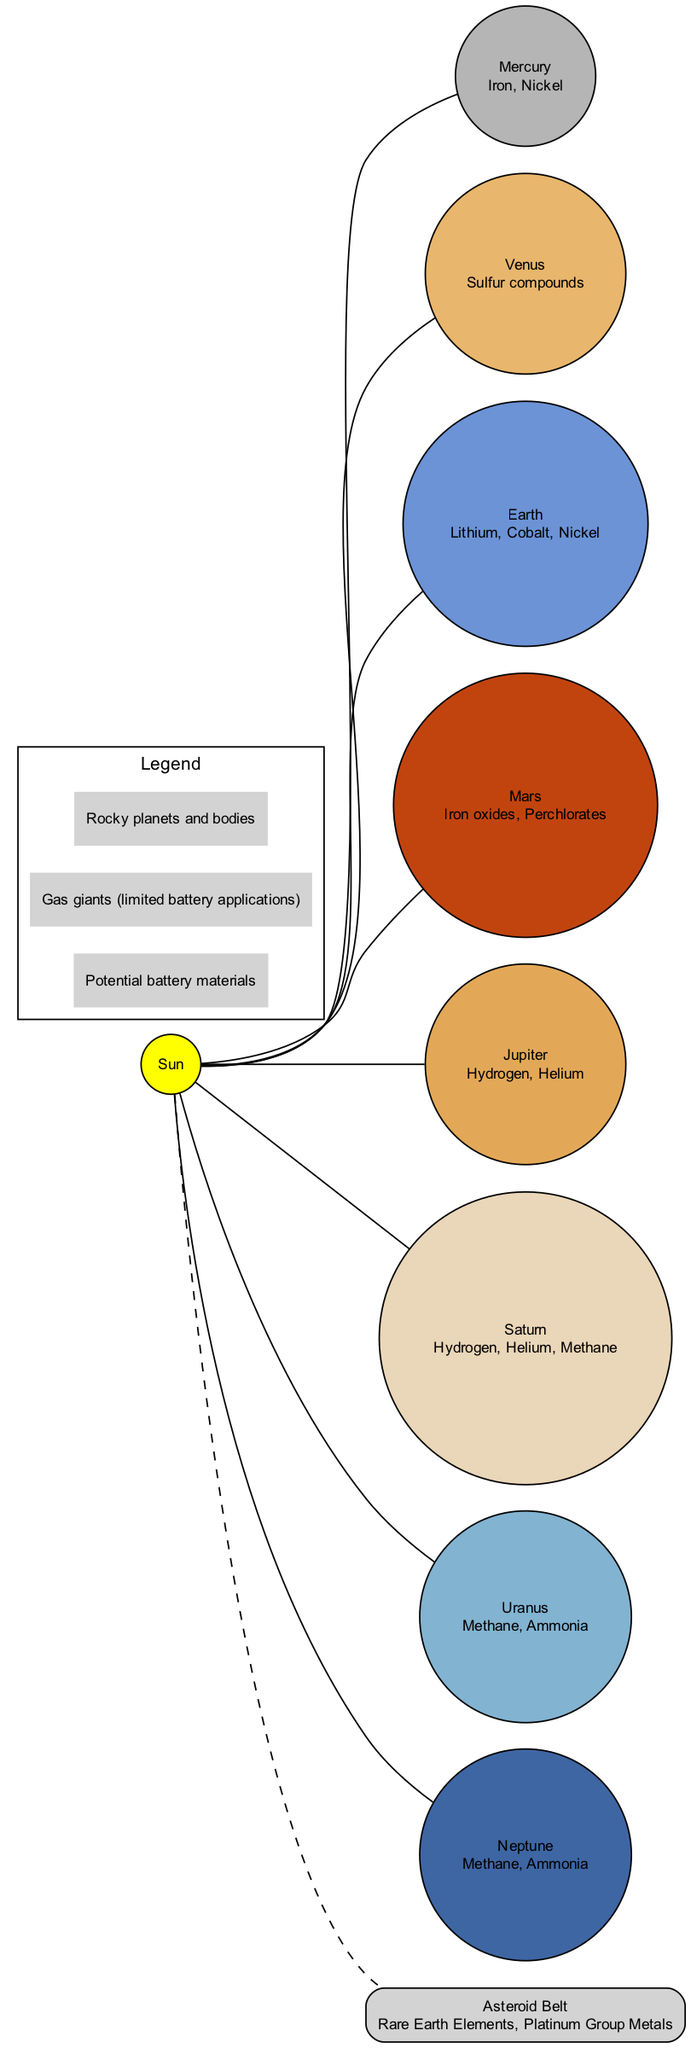What materials are found on Earth? The diagram specifies that Earth has Lithium, Cobalt, and Nickel as its materials. These materials are listed directly under the Earth node in the diagram.
Answer: Lithium, Cobalt, Nickel Which planets contain Hydrogen? The diagram identifies that both Jupiter and Saturn contain Hydrogen, as indicated in their respective materials listed below the planet names.
Answer: Jupiter, Saturn How many rocky planets are shown in the diagram? The diagram visually represents four rocky planets: Mercury, Venus, Earth, and Mars. This can be inferred by counting the nodes that do not belong to gas giants or the asteroid belt.
Answer: 4 What is the primary material found in Venus? The diagram notes that Venus is comprised primarily of Sulfur compounds, which is indicated directly below the Venus node.
Answer: Sulfur compounds Where are Rare Earth Elements found in the solar system? Rare Earth Elements are listed as being found in the Asteroid Belt, which is located between Mars and Jupiter, as shown in the diagram.
Answer: Asteroid Belt What color represents Mars in the diagram? The diagram uses the color #C1440E to represent Mars, which can be identified by looking at the color coding associated with the Mars node.
Answer: #C1440E Which planet has Iron oxides and Perchlorates? According to the diagram, Mars is indicated to have Iron oxides and Perchlorates listed beneath its name.
Answer: Mars Which materials are labeled under the Asteroid Belt? Under the Asteroid Belt node, the diagram states that Rare Earth Elements and Platinum Group Metals are the materials found there.
Answer: Rare Earth Elements, Platinum Group Metals What kind of planets are Jupiter and Saturn classified as? In the diagram, both Jupiter and Saturn are classified as gas giants, which is indicated under the legend section that describes their limited battery applications.
Answer: Gas giants 